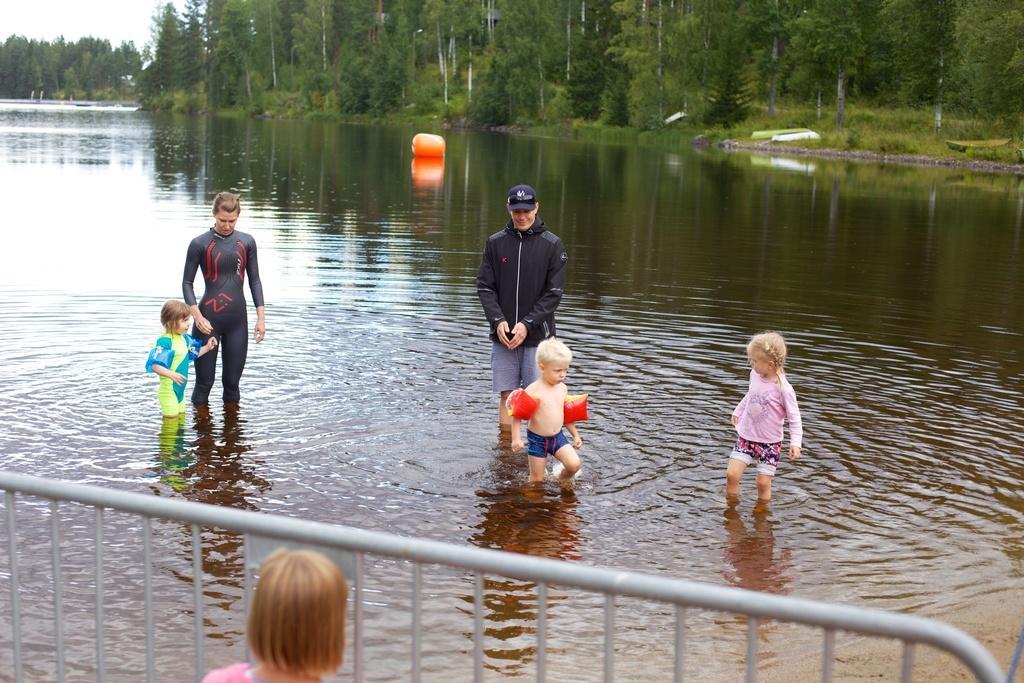Please provide a concise description of this image. In the center of the image we can see persons in the water. At the bottom of the image we can see fencing and person. In the background we can see water, balloon, trees, grass and sky. 